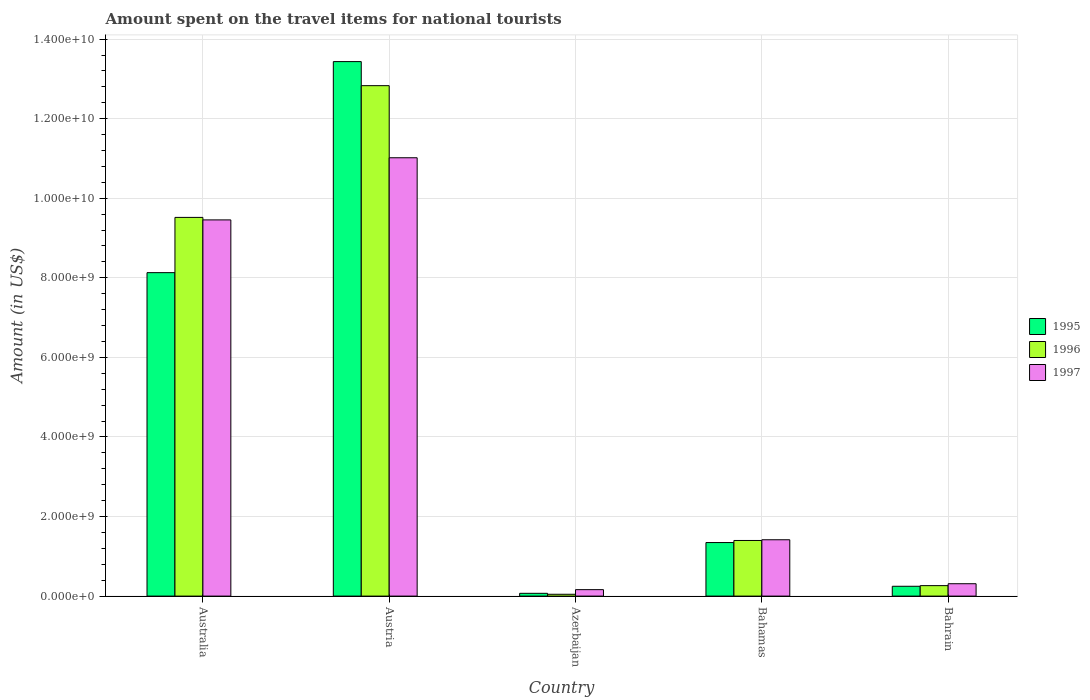How many different coloured bars are there?
Provide a succinct answer. 3. Are the number of bars per tick equal to the number of legend labels?
Ensure brevity in your answer.  Yes. How many bars are there on the 1st tick from the right?
Offer a very short reply. 3. What is the label of the 2nd group of bars from the left?
Provide a succinct answer. Austria. In how many cases, is the number of bars for a given country not equal to the number of legend labels?
Make the answer very short. 0. What is the amount spent on the travel items for national tourists in 1996 in Azerbaijan?
Provide a succinct answer. 4.60e+07. Across all countries, what is the maximum amount spent on the travel items for national tourists in 1996?
Your answer should be very brief. 1.28e+1. Across all countries, what is the minimum amount spent on the travel items for national tourists in 1995?
Your answer should be very brief. 7.00e+07. In which country was the amount spent on the travel items for national tourists in 1996 maximum?
Your response must be concise. Austria. In which country was the amount spent on the travel items for national tourists in 1997 minimum?
Offer a very short reply. Azerbaijan. What is the total amount spent on the travel items for national tourists in 1997 in the graph?
Your response must be concise. 2.24e+1. What is the difference between the amount spent on the travel items for national tourists in 1997 in Australia and that in Bahamas?
Offer a very short reply. 8.04e+09. What is the difference between the amount spent on the travel items for national tourists in 1997 in Bahamas and the amount spent on the travel items for national tourists in 1995 in Australia?
Offer a terse response. -6.71e+09. What is the average amount spent on the travel items for national tourists in 1996 per country?
Give a very brief answer. 4.81e+09. What is the difference between the amount spent on the travel items for national tourists of/in 1995 and amount spent on the travel items for national tourists of/in 1996 in Azerbaijan?
Provide a succinct answer. 2.40e+07. In how many countries, is the amount spent on the travel items for national tourists in 1995 greater than 800000000 US$?
Ensure brevity in your answer.  3. What is the ratio of the amount spent on the travel items for national tourists in 1997 in Azerbaijan to that in Bahamas?
Ensure brevity in your answer.  0.11. Is the difference between the amount spent on the travel items for national tourists in 1995 in Australia and Bahrain greater than the difference between the amount spent on the travel items for national tourists in 1996 in Australia and Bahrain?
Offer a terse response. No. What is the difference between the highest and the second highest amount spent on the travel items for national tourists in 1996?
Your answer should be very brief. 1.14e+1. What is the difference between the highest and the lowest amount spent on the travel items for national tourists in 1997?
Offer a very short reply. 1.09e+1. In how many countries, is the amount spent on the travel items for national tourists in 1997 greater than the average amount spent on the travel items for national tourists in 1997 taken over all countries?
Offer a very short reply. 2. Is the sum of the amount spent on the travel items for national tourists in 1997 in Australia and Bahrain greater than the maximum amount spent on the travel items for national tourists in 1996 across all countries?
Provide a short and direct response. No. How many bars are there?
Provide a short and direct response. 15. Are all the bars in the graph horizontal?
Your response must be concise. No. How many countries are there in the graph?
Provide a succinct answer. 5. What is the difference between two consecutive major ticks on the Y-axis?
Your answer should be compact. 2.00e+09. Are the values on the major ticks of Y-axis written in scientific E-notation?
Your answer should be compact. Yes. Does the graph contain any zero values?
Your answer should be compact. No. Does the graph contain grids?
Provide a succinct answer. Yes. Where does the legend appear in the graph?
Make the answer very short. Center right. What is the title of the graph?
Provide a short and direct response. Amount spent on the travel items for national tourists. Does "2009" appear as one of the legend labels in the graph?
Provide a succinct answer. No. What is the label or title of the X-axis?
Offer a terse response. Country. What is the Amount (in US$) in 1995 in Australia?
Provide a succinct answer. 8.13e+09. What is the Amount (in US$) in 1996 in Australia?
Offer a terse response. 9.52e+09. What is the Amount (in US$) in 1997 in Australia?
Make the answer very short. 9.46e+09. What is the Amount (in US$) in 1995 in Austria?
Your answer should be compact. 1.34e+1. What is the Amount (in US$) of 1996 in Austria?
Offer a very short reply. 1.28e+1. What is the Amount (in US$) in 1997 in Austria?
Ensure brevity in your answer.  1.10e+1. What is the Amount (in US$) of 1995 in Azerbaijan?
Your answer should be compact. 7.00e+07. What is the Amount (in US$) of 1996 in Azerbaijan?
Provide a succinct answer. 4.60e+07. What is the Amount (in US$) of 1997 in Azerbaijan?
Offer a terse response. 1.62e+08. What is the Amount (in US$) in 1995 in Bahamas?
Give a very brief answer. 1.35e+09. What is the Amount (in US$) of 1996 in Bahamas?
Make the answer very short. 1.40e+09. What is the Amount (in US$) of 1997 in Bahamas?
Provide a short and direct response. 1.42e+09. What is the Amount (in US$) of 1995 in Bahrain?
Provide a succinct answer. 2.47e+08. What is the Amount (in US$) of 1996 in Bahrain?
Offer a terse response. 2.63e+08. What is the Amount (in US$) in 1997 in Bahrain?
Your response must be concise. 3.11e+08. Across all countries, what is the maximum Amount (in US$) of 1995?
Keep it short and to the point. 1.34e+1. Across all countries, what is the maximum Amount (in US$) of 1996?
Give a very brief answer. 1.28e+1. Across all countries, what is the maximum Amount (in US$) of 1997?
Offer a very short reply. 1.10e+1. Across all countries, what is the minimum Amount (in US$) in 1995?
Make the answer very short. 7.00e+07. Across all countries, what is the minimum Amount (in US$) in 1996?
Offer a terse response. 4.60e+07. Across all countries, what is the minimum Amount (in US$) of 1997?
Your response must be concise. 1.62e+08. What is the total Amount (in US$) of 1995 in the graph?
Give a very brief answer. 2.32e+1. What is the total Amount (in US$) of 1996 in the graph?
Make the answer very short. 2.41e+1. What is the total Amount (in US$) of 1997 in the graph?
Give a very brief answer. 2.24e+1. What is the difference between the Amount (in US$) of 1995 in Australia and that in Austria?
Offer a terse response. -5.30e+09. What is the difference between the Amount (in US$) in 1996 in Australia and that in Austria?
Provide a short and direct response. -3.31e+09. What is the difference between the Amount (in US$) in 1997 in Australia and that in Austria?
Your answer should be compact. -1.56e+09. What is the difference between the Amount (in US$) of 1995 in Australia and that in Azerbaijan?
Offer a terse response. 8.06e+09. What is the difference between the Amount (in US$) in 1996 in Australia and that in Azerbaijan?
Provide a succinct answer. 9.47e+09. What is the difference between the Amount (in US$) of 1997 in Australia and that in Azerbaijan?
Give a very brief answer. 9.29e+09. What is the difference between the Amount (in US$) of 1995 in Australia and that in Bahamas?
Provide a short and direct response. 6.78e+09. What is the difference between the Amount (in US$) of 1996 in Australia and that in Bahamas?
Offer a very short reply. 8.12e+09. What is the difference between the Amount (in US$) in 1997 in Australia and that in Bahamas?
Offer a terse response. 8.04e+09. What is the difference between the Amount (in US$) in 1995 in Australia and that in Bahrain?
Ensure brevity in your answer.  7.88e+09. What is the difference between the Amount (in US$) of 1996 in Australia and that in Bahrain?
Provide a succinct answer. 9.26e+09. What is the difference between the Amount (in US$) of 1997 in Australia and that in Bahrain?
Make the answer very short. 9.14e+09. What is the difference between the Amount (in US$) in 1995 in Austria and that in Azerbaijan?
Provide a succinct answer. 1.34e+1. What is the difference between the Amount (in US$) of 1996 in Austria and that in Azerbaijan?
Keep it short and to the point. 1.28e+1. What is the difference between the Amount (in US$) of 1997 in Austria and that in Azerbaijan?
Ensure brevity in your answer.  1.09e+1. What is the difference between the Amount (in US$) of 1995 in Austria and that in Bahamas?
Offer a terse response. 1.21e+1. What is the difference between the Amount (in US$) in 1996 in Austria and that in Bahamas?
Your answer should be compact. 1.14e+1. What is the difference between the Amount (in US$) in 1997 in Austria and that in Bahamas?
Your response must be concise. 9.60e+09. What is the difference between the Amount (in US$) of 1995 in Austria and that in Bahrain?
Provide a succinct answer. 1.32e+1. What is the difference between the Amount (in US$) of 1996 in Austria and that in Bahrain?
Your answer should be compact. 1.26e+1. What is the difference between the Amount (in US$) of 1997 in Austria and that in Bahrain?
Make the answer very short. 1.07e+1. What is the difference between the Amount (in US$) of 1995 in Azerbaijan and that in Bahamas?
Your answer should be very brief. -1.28e+09. What is the difference between the Amount (in US$) in 1996 in Azerbaijan and that in Bahamas?
Keep it short and to the point. -1.35e+09. What is the difference between the Amount (in US$) in 1997 in Azerbaijan and that in Bahamas?
Your answer should be very brief. -1.25e+09. What is the difference between the Amount (in US$) in 1995 in Azerbaijan and that in Bahrain?
Provide a short and direct response. -1.77e+08. What is the difference between the Amount (in US$) in 1996 in Azerbaijan and that in Bahrain?
Ensure brevity in your answer.  -2.17e+08. What is the difference between the Amount (in US$) in 1997 in Azerbaijan and that in Bahrain?
Keep it short and to the point. -1.49e+08. What is the difference between the Amount (in US$) of 1995 in Bahamas and that in Bahrain?
Give a very brief answer. 1.10e+09. What is the difference between the Amount (in US$) of 1996 in Bahamas and that in Bahrain?
Keep it short and to the point. 1.14e+09. What is the difference between the Amount (in US$) of 1997 in Bahamas and that in Bahrain?
Your response must be concise. 1.10e+09. What is the difference between the Amount (in US$) of 1995 in Australia and the Amount (in US$) of 1996 in Austria?
Provide a short and direct response. -4.70e+09. What is the difference between the Amount (in US$) of 1995 in Australia and the Amount (in US$) of 1997 in Austria?
Your answer should be very brief. -2.89e+09. What is the difference between the Amount (in US$) in 1996 in Australia and the Amount (in US$) in 1997 in Austria?
Your response must be concise. -1.50e+09. What is the difference between the Amount (in US$) of 1995 in Australia and the Amount (in US$) of 1996 in Azerbaijan?
Keep it short and to the point. 8.08e+09. What is the difference between the Amount (in US$) in 1995 in Australia and the Amount (in US$) in 1997 in Azerbaijan?
Provide a succinct answer. 7.97e+09. What is the difference between the Amount (in US$) in 1996 in Australia and the Amount (in US$) in 1997 in Azerbaijan?
Ensure brevity in your answer.  9.36e+09. What is the difference between the Amount (in US$) in 1995 in Australia and the Amount (in US$) in 1996 in Bahamas?
Your answer should be compact. 6.73e+09. What is the difference between the Amount (in US$) in 1995 in Australia and the Amount (in US$) in 1997 in Bahamas?
Your response must be concise. 6.71e+09. What is the difference between the Amount (in US$) of 1996 in Australia and the Amount (in US$) of 1997 in Bahamas?
Provide a succinct answer. 8.10e+09. What is the difference between the Amount (in US$) of 1995 in Australia and the Amount (in US$) of 1996 in Bahrain?
Make the answer very short. 7.87e+09. What is the difference between the Amount (in US$) of 1995 in Australia and the Amount (in US$) of 1997 in Bahrain?
Your response must be concise. 7.82e+09. What is the difference between the Amount (in US$) in 1996 in Australia and the Amount (in US$) in 1997 in Bahrain?
Your answer should be compact. 9.21e+09. What is the difference between the Amount (in US$) of 1995 in Austria and the Amount (in US$) of 1996 in Azerbaijan?
Offer a terse response. 1.34e+1. What is the difference between the Amount (in US$) of 1995 in Austria and the Amount (in US$) of 1997 in Azerbaijan?
Offer a terse response. 1.33e+1. What is the difference between the Amount (in US$) in 1996 in Austria and the Amount (in US$) in 1997 in Azerbaijan?
Provide a short and direct response. 1.27e+1. What is the difference between the Amount (in US$) in 1995 in Austria and the Amount (in US$) in 1996 in Bahamas?
Your response must be concise. 1.20e+1. What is the difference between the Amount (in US$) in 1995 in Austria and the Amount (in US$) in 1997 in Bahamas?
Your response must be concise. 1.20e+1. What is the difference between the Amount (in US$) of 1996 in Austria and the Amount (in US$) of 1997 in Bahamas?
Offer a very short reply. 1.14e+1. What is the difference between the Amount (in US$) in 1995 in Austria and the Amount (in US$) in 1996 in Bahrain?
Ensure brevity in your answer.  1.32e+1. What is the difference between the Amount (in US$) of 1995 in Austria and the Amount (in US$) of 1997 in Bahrain?
Keep it short and to the point. 1.31e+1. What is the difference between the Amount (in US$) in 1996 in Austria and the Amount (in US$) in 1997 in Bahrain?
Provide a succinct answer. 1.25e+1. What is the difference between the Amount (in US$) of 1995 in Azerbaijan and the Amount (in US$) of 1996 in Bahamas?
Ensure brevity in your answer.  -1.33e+09. What is the difference between the Amount (in US$) of 1995 in Azerbaijan and the Amount (in US$) of 1997 in Bahamas?
Provide a short and direct response. -1.35e+09. What is the difference between the Amount (in US$) of 1996 in Azerbaijan and the Amount (in US$) of 1997 in Bahamas?
Keep it short and to the point. -1.37e+09. What is the difference between the Amount (in US$) in 1995 in Azerbaijan and the Amount (in US$) in 1996 in Bahrain?
Offer a very short reply. -1.93e+08. What is the difference between the Amount (in US$) in 1995 in Azerbaijan and the Amount (in US$) in 1997 in Bahrain?
Give a very brief answer. -2.41e+08. What is the difference between the Amount (in US$) of 1996 in Azerbaijan and the Amount (in US$) of 1997 in Bahrain?
Keep it short and to the point. -2.65e+08. What is the difference between the Amount (in US$) of 1995 in Bahamas and the Amount (in US$) of 1996 in Bahrain?
Keep it short and to the point. 1.08e+09. What is the difference between the Amount (in US$) of 1995 in Bahamas and the Amount (in US$) of 1997 in Bahrain?
Make the answer very short. 1.04e+09. What is the difference between the Amount (in US$) of 1996 in Bahamas and the Amount (in US$) of 1997 in Bahrain?
Your response must be concise. 1.09e+09. What is the average Amount (in US$) of 1995 per country?
Offer a very short reply. 4.65e+09. What is the average Amount (in US$) in 1996 per country?
Provide a succinct answer. 4.81e+09. What is the average Amount (in US$) in 1997 per country?
Your response must be concise. 4.47e+09. What is the difference between the Amount (in US$) in 1995 and Amount (in US$) in 1996 in Australia?
Your answer should be very brief. -1.39e+09. What is the difference between the Amount (in US$) in 1995 and Amount (in US$) in 1997 in Australia?
Make the answer very short. -1.33e+09. What is the difference between the Amount (in US$) of 1996 and Amount (in US$) of 1997 in Australia?
Keep it short and to the point. 6.30e+07. What is the difference between the Amount (in US$) in 1995 and Amount (in US$) in 1996 in Austria?
Offer a very short reply. 6.05e+08. What is the difference between the Amount (in US$) of 1995 and Amount (in US$) of 1997 in Austria?
Offer a very short reply. 2.42e+09. What is the difference between the Amount (in US$) in 1996 and Amount (in US$) in 1997 in Austria?
Make the answer very short. 1.81e+09. What is the difference between the Amount (in US$) in 1995 and Amount (in US$) in 1996 in Azerbaijan?
Offer a very short reply. 2.40e+07. What is the difference between the Amount (in US$) in 1995 and Amount (in US$) in 1997 in Azerbaijan?
Your answer should be very brief. -9.20e+07. What is the difference between the Amount (in US$) of 1996 and Amount (in US$) of 1997 in Azerbaijan?
Ensure brevity in your answer.  -1.16e+08. What is the difference between the Amount (in US$) of 1995 and Amount (in US$) of 1996 in Bahamas?
Ensure brevity in your answer.  -5.20e+07. What is the difference between the Amount (in US$) in 1995 and Amount (in US$) in 1997 in Bahamas?
Provide a succinct answer. -7.00e+07. What is the difference between the Amount (in US$) in 1996 and Amount (in US$) in 1997 in Bahamas?
Keep it short and to the point. -1.80e+07. What is the difference between the Amount (in US$) in 1995 and Amount (in US$) in 1996 in Bahrain?
Make the answer very short. -1.60e+07. What is the difference between the Amount (in US$) in 1995 and Amount (in US$) in 1997 in Bahrain?
Offer a terse response. -6.40e+07. What is the difference between the Amount (in US$) in 1996 and Amount (in US$) in 1997 in Bahrain?
Ensure brevity in your answer.  -4.80e+07. What is the ratio of the Amount (in US$) in 1995 in Australia to that in Austria?
Make the answer very short. 0.61. What is the ratio of the Amount (in US$) in 1996 in Australia to that in Austria?
Your response must be concise. 0.74. What is the ratio of the Amount (in US$) in 1997 in Australia to that in Austria?
Provide a succinct answer. 0.86. What is the ratio of the Amount (in US$) of 1995 in Australia to that in Azerbaijan?
Your answer should be very brief. 116.14. What is the ratio of the Amount (in US$) of 1996 in Australia to that in Azerbaijan?
Your response must be concise. 206.93. What is the ratio of the Amount (in US$) of 1997 in Australia to that in Azerbaijan?
Provide a succinct answer. 58.37. What is the ratio of the Amount (in US$) of 1995 in Australia to that in Bahamas?
Your answer should be compact. 6.04. What is the ratio of the Amount (in US$) of 1996 in Australia to that in Bahamas?
Make the answer very short. 6.81. What is the ratio of the Amount (in US$) of 1997 in Australia to that in Bahamas?
Provide a short and direct response. 6.68. What is the ratio of the Amount (in US$) of 1995 in Australia to that in Bahrain?
Your answer should be compact. 32.91. What is the ratio of the Amount (in US$) of 1996 in Australia to that in Bahrain?
Provide a succinct answer. 36.19. What is the ratio of the Amount (in US$) of 1997 in Australia to that in Bahrain?
Your answer should be compact. 30.41. What is the ratio of the Amount (in US$) in 1995 in Austria to that in Azerbaijan?
Provide a short and direct response. 191.93. What is the ratio of the Amount (in US$) in 1996 in Austria to that in Azerbaijan?
Your answer should be very brief. 278.91. What is the ratio of the Amount (in US$) of 1997 in Austria to that in Azerbaijan?
Make the answer very short. 68.01. What is the ratio of the Amount (in US$) in 1995 in Austria to that in Bahamas?
Give a very brief answer. 9.98. What is the ratio of the Amount (in US$) of 1996 in Austria to that in Bahamas?
Provide a succinct answer. 9.18. What is the ratio of the Amount (in US$) in 1997 in Austria to that in Bahamas?
Keep it short and to the point. 7.78. What is the ratio of the Amount (in US$) in 1995 in Austria to that in Bahrain?
Provide a short and direct response. 54.39. What is the ratio of the Amount (in US$) of 1996 in Austria to that in Bahrain?
Keep it short and to the point. 48.78. What is the ratio of the Amount (in US$) in 1997 in Austria to that in Bahrain?
Your response must be concise. 35.43. What is the ratio of the Amount (in US$) in 1995 in Azerbaijan to that in Bahamas?
Offer a terse response. 0.05. What is the ratio of the Amount (in US$) in 1996 in Azerbaijan to that in Bahamas?
Your answer should be very brief. 0.03. What is the ratio of the Amount (in US$) of 1997 in Azerbaijan to that in Bahamas?
Make the answer very short. 0.11. What is the ratio of the Amount (in US$) of 1995 in Azerbaijan to that in Bahrain?
Your response must be concise. 0.28. What is the ratio of the Amount (in US$) of 1996 in Azerbaijan to that in Bahrain?
Offer a very short reply. 0.17. What is the ratio of the Amount (in US$) of 1997 in Azerbaijan to that in Bahrain?
Make the answer very short. 0.52. What is the ratio of the Amount (in US$) in 1995 in Bahamas to that in Bahrain?
Ensure brevity in your answer.  5.45. What is the ratio of the Amount (in US$) in 1996 in Bahamas to that in Bahrain?
Give a very brief answer. 5.32. What is the ratio of the Amount (in US$) of 1997 in Bahamas to that in Bahrain?
Offer a terse response. 4.55. What is the difference between the highest and the second highest Amount (in US$) in 1995?
Give a very brief answer. 5.30e+09. What is the difference between the highest and the second highest Amount (in US$) of 1996?
Keep it short and to the point. 3.31e+09. What is the difference between the highest and the second highest Amount (in US$) of 1997?
Offer a very short reply. 1.56e+09. What is the difference between the highest and the lowest Amount (in US$) of 1995?
Provide a short and direct response. 1.34e+1. What is the difference between the highest and the lowest Amount (in US$) of 1996?
Your answer should be compact. 1.28e+1. What is the difference between the highest and the lowest Amount (in US$) in 1997?
Your answer should be compact. 1.09e+1. 